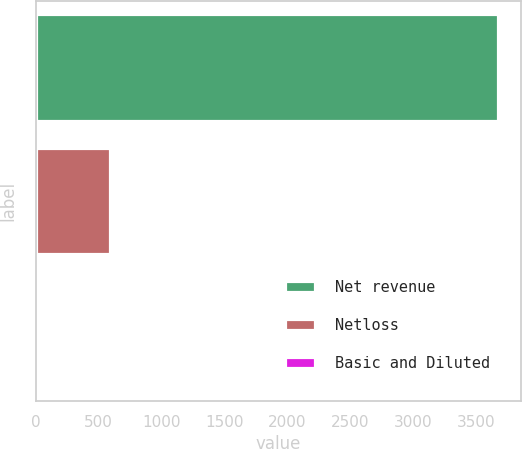Convert chart. <chart><loc_0><loc_0><loc_500><loc_500><bar_chart><fcel>Net revenue<fcel>Netloss<fcel>Basic and Diluted<nl><fcel>3672<fcel>592<fcel>1.89<nl></chart> 